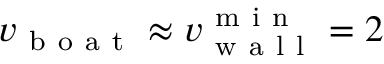Convert formula to latex. <formula><loc_0><loc_0><loc_500><loc_500>v _ { b o a t } \approx v _ { w a l l } ^ { m i n } = 2</formula> 